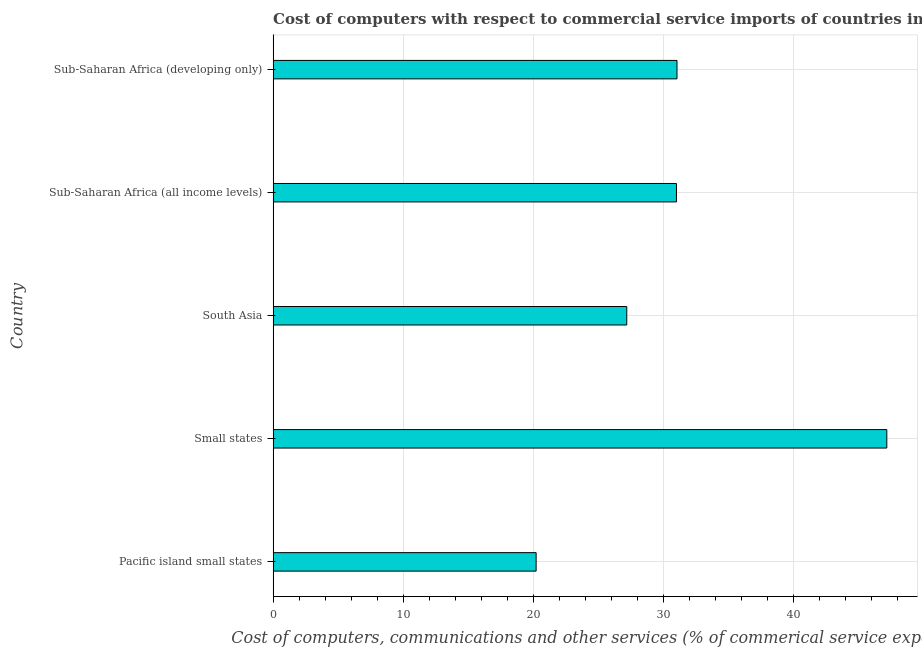Does the graph contain any zero values?
Offer a very short reply. No. What is the title of the graph?
Give a very brief answer. Cost of computers with respect to commercial service imports of countries in 2011. What is the label or title of the X-axis?
Your response must be concise. Cost of computers, communications and other services (% of commerical service exports). What is the label or title of the Y-axis?
Offer a very short reply. Country. What is the cost of communications in Small states?
Keep it short and to the point. 47.15. Across all countries, what is the maximum cost of communications?
Your response must be concise. 47.15. Across all countries, what is the minimum cost of communications?
Keep it short and to the point. 20.21. In which country was the  computer and other services maximum?
Make the answer very short. Small states. In which country was the cost of communications minimum?
Make the answer very short. Pacific island small states. What is the sum of the cost of communications?
Provide a short and direct response. 156.55. What is the difference between the cost of communications in Pacific island small states and Small states?
Your answer should be compact. -26.94. What is the average  computer and other services per country?
Keep it short and to the point. 31.31. What is the median cost of communications?
Your response must be concise. 30.99. In how many countries, is the  computer and other services greater than 6 %?
Your answer should be very brief. 5. What is the difference between the highest and the second highest  computer and other services?
Provide a succinct answer. 16.12. Is the sum of the  computer and other services in Small states and Sub-Saharan Africa (developing only) greater than the maximum  computer and other services across all countries?
Ensure brevity in your answer.  Yes. What is the difference between the highest and the lowest  computer and other services?
Your response must be concise. 26.94. How many bars are there?
Your answer should be compact. 5. What is the Cost of computers, communications and other services (% of commerical service exports) in Pacific island small states?
Ensure brevity in your answer.  20.21. What is the Cost of computers, communications and other services (% of commerical service exports) of Small states?
Your response must be concise. 47.15. What is the Cost of computers, communications and other services (% of commerical service exports) in South Asia?
Offer a terse response. 27.17. What is the Cost of computers, communications and other services (% of commerical service exports) in Sub-Saharan Africa (all income levels)?
Provide a short and direct response. 30.99. What is the Cost of computers, communications and other services (% of commerical service exports) of Sub-Saharan Africa (developing only)?
Make the answer very short. 31.03. What is the difference between the Cost of computers, communications and other services (% of commerical service exports) in Pacific island small states and Small states?
Keep it short and to the point. -26.94. What is the difference between the Cost of computers, communications and other services (% of commerical service exports) in Pacific island small states and South Asia?
Offer a terse response. -6.96. What is the difference between the Cost of computers, communications and other services (% of commerical service exports) in Pacific island small states and Sub-Saharan Africa (all income levels)?
Provide a succinct answer. -10.78. What is the difference between the Cost of computers, communications and other services (% of commerical service exports) in Pacific island small states and Sub-Saharan Africa (developing only)?
Make the answer very short. -10.82. What is the difference between the Cost of computers, communications and other services (% of commerical service exports) in Small states and South Asia?
Ensure brevity in your answer.  19.98. What is the difference between the Cost of computers, communications and other services (% of commerical service exports) in Small states and Sub-Saharan Africa (all income levels)?
Give a very brief answer. 16.16. What is the difference between the Cost of computers, communications and other services (% of commerical service exports) in Small states and Sub-Saharan Africa (developing only)?
Make the answer very short. 16.12. What is the difference between the Cost of computers, communications and other services (% of commerical service exports) in South Asia and Sub-Saharan Africa (all income levels)?
Offer a terse response. -3.82. What is the difference between the Cost of computers, communications and other services (% of commerical service exports) in South Asia and Sub-Saharan Africa (developing only)?
Offer a terse response. -3.86. What is the difference between the Cost of computers, communications and other services (% of commerical service exports) in Sub-Saharan Africa (all income levels) and Sub-Saharan Africa (developing only)?
Keep it short and to the point. -0.04. What is the ratio of the Cost of computers, communications and other services (% of commerical service exports) in Pacific island small states to that in Small states?
Provide a succinct answer. 0.43. What is the ratio of the Cost of computers, communications and other services (% of commerical service exports) in Pacific island small states to that in South Asia?
Your answer should be very brief. 0.74. What is the ratio of the Cost of computers, communications and other services (% of commerical service exports) in Pacific island small states to that in Sub-Saharan Africa (all income levels)?
Keep it short and to the point. 0.65. What is the ratio of the Cost of computers, communications and other services (% of commerical service exports) in Pacific island small states to that in Sub-Saharan Africa (developing only)?
Ensure brevity in your answer.  0.65. What is the ratio of the Cost of computers, communications and other services (% of commerical service exports) in Small states to that in South Asia?
Make the answer very short. 1.74. What is the ratio of the Cost of computers, communications and other services (% of commerical service exports) in Small states to that in Sub-Saharan Africa (all income levels)?
Offer a very short reply. 1.52. What is the ratio of the Cost of computers, communications and other services (% of commerical service exports) in Small states to that in Sub-Saharan Africa (developing only)?
Provide a short and direct response. 1.52. What is the ratio of the Cost of computers, communications and other services (% of commerical service exports) in South Asia to that in Sub-Saharan Africa (all income levels)?
Give a very brief answer. 0.88. What is the ratio of the Cost of computers, communications and other services (% of commerical service exports) in South Asia to that in Sub-Saharan Africa (developing only)?
Provide a short and direct response. 0.88. 